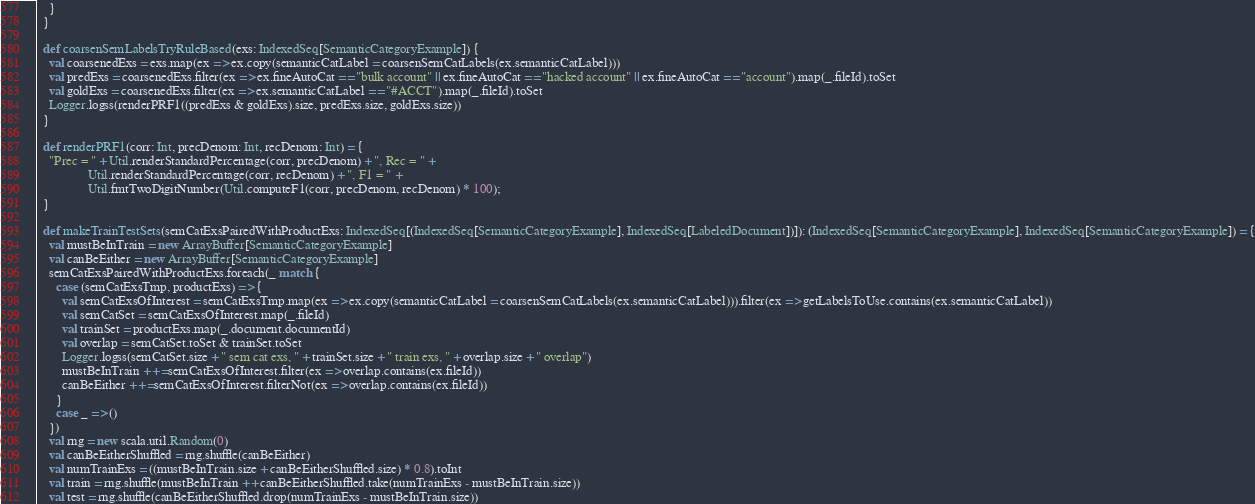<code> <loc_0><loc_0><loc_500><loc_500><_Scala_>    }
  }
  
  def coarsenSemLabelsTryRuleBased(exs: IndexedSeq[SemanticCategoryExample]) {
    val coarsenedExs = exs.map(ex => ex.copy(semanticCatLabel = coarsenSemCatLabels(ex.semanticCatLabel)))
    val predExs = coarsenedExs.filter(ex => ex.fineAutoCat == "bulk account" || ex.fineAutoCat == "hacked account" || ex.fineAutoCat == "account").map(_.fileId).toSet
    val goldExs = coarsenedExs.filter(ex => ex.semanticCatLabel == "#ACCT").map(_.fileId).toSet
    Logger.logss(renderPRF1((predExs & goldExs).size, predExs.size, goldExs.size))
  }
  
  def renderPRF1(corr: Int, precDenom: Int, recDenom: Int) = {
    "Prec = " + Util.renderStandardPercentage(corr, precDenom) + ", Rec = " +
                Util.renderStandardPercentage(corr, recDenom) + ", F1 = " +
                Util.fmtTwoDigitNumber(Util.computeF1(corr, precDenom, recDenom) * 100); 
  }
  
  def makeTrainTestSets(semCatExsPairedWithProductExs: IndexedSeq[(IndexedSeq[SemanticCategoryExample], IndexedSeq[LabeledDocument])]): (IndexedSeq[SemanticCategoryExample], IndexedSeq[SemanticCategoryExample]) = {
    val mustBeInTrain = new ArrayBuffer[SemanticCategoryExample]
    val canBeEither = new ArrayBuffer[SemanticCategoryExample]
    semCatExsPairedWithProductExs.foreach(_ match {
      case (semCatExsTmp, productExs) => {
        val semCatExsOfInterest = semCatExsTmp.map(ex => ex.copy(semanticCatLabel = coarsenSemCatLabels(ex.semanticCatLabel))).filter(ex => getLabelsToUse.contains(ex.semanticCatLabel))
        val semCatSet = semCatExsOfInterest.map(_.fileId)
        val trainSet = productExs.map(_.document.documentId)
        val overlap = semCatSet.toSet & trainSet.toSet
        Logger.logss(semCatSet.size + " sem cat exs, " + trainSet.size + " train exs, " + overlap.size + " overlap")
        mustBeInTrain ++= semCatExsOfInterest.filter(ex => overlap.contains(ex.fileId))
        canBeEither ++= semCatExsOfInterest.filterNot(ex => overlap.contains(ex.fileId))
      }
      case _ => ()
    })
    val rng = new scala.util.Random(0)
    val canBeEitherShuffled = rng.shuffle(canBeEither)
    val numTrainExs = ((mustBeInTrain.size + canBeEitherShuffled.size) * 0.8).toInt
    val train = rng.shuffle(mustBeInTrain ++ canBeEitherShuffled.take(numTrainExs - mustBeInTrain.size))
    val test = rng.shuffle(canBeEitherShuffled.drop(numTrainExs - mustBeInTrain.size))</code> 